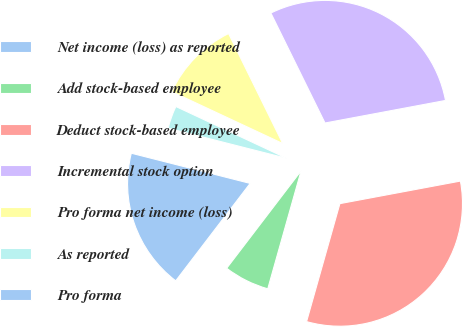Convert chart to OTSL. <chart><loc_0><loc_0><loc_500><loc_500><pie_chart><fcel>Net income (loss) as reported<fcel>Add stock-based employee<fcel>Deduct stock-based employee<fcel>Incremental stock option<fcel>Pro forma net income (loss)<fcel>As reported<fcel>Pro forma<nl><fcel>18.58%<fcel>6.0%<fcel>32.33%<fcel>29.34%<fcel>10.76%<fcel>3.0%<fcel>0.0%<nl></chart> 